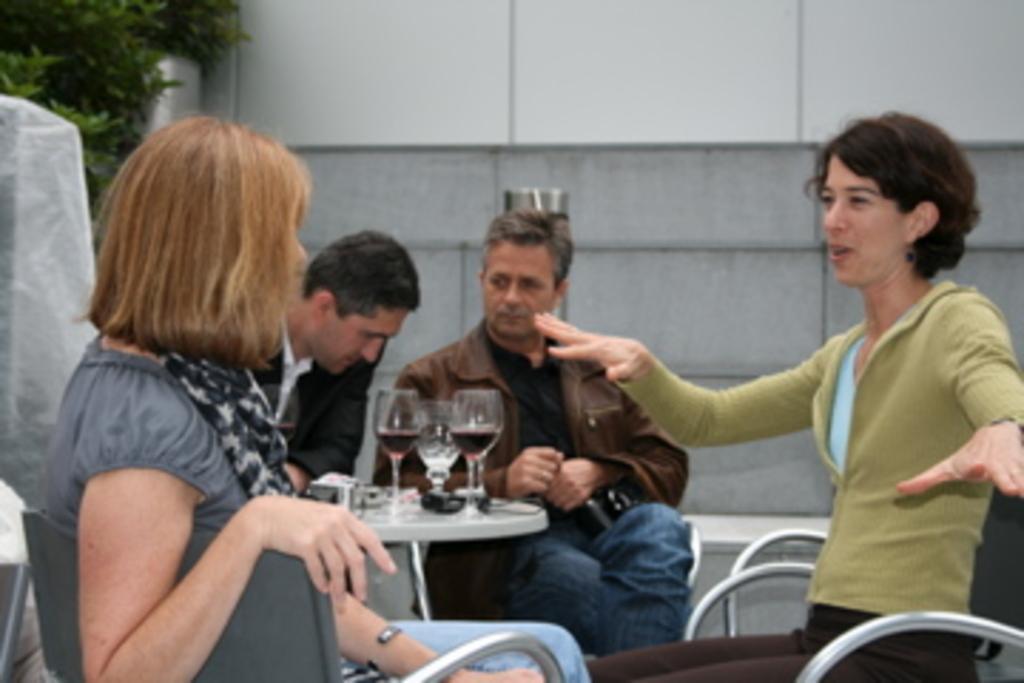Can you describe this image briefly? There are four people sitting on chairs and we can see glasses and objects on table. Background we can see wall and leaves. 